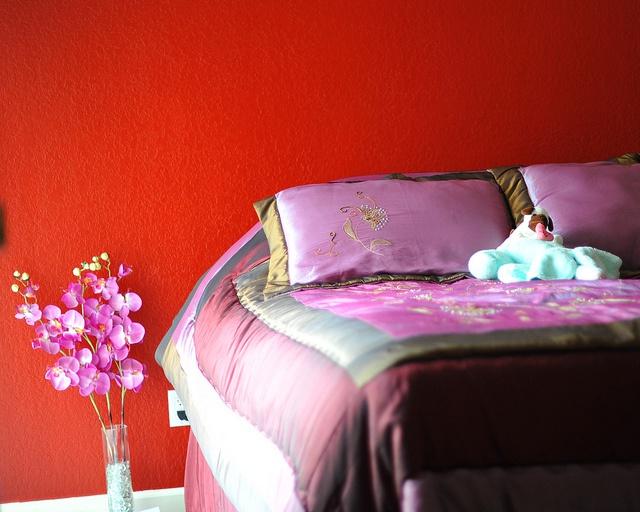Describe the objects in this image and their specific colors. I can see bed in brown, black, lavender, and violet tones, teddy bear in brown, white, turquoise, and gray tones, and vase in brown, ivory, salmon, darkgray, and lightpink tones in this image. 